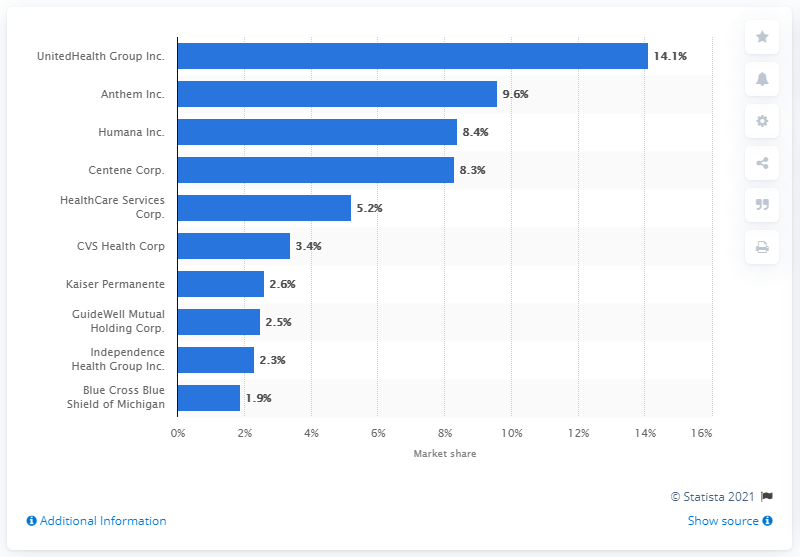Highlight a few significant elements in this photo. In 2019, Anthem Inc and Humana Inc held a combined market share of 9.6%. In 2019, UnitedHealth Group held approximately 14.1% of the total health insurance market in the United States. 